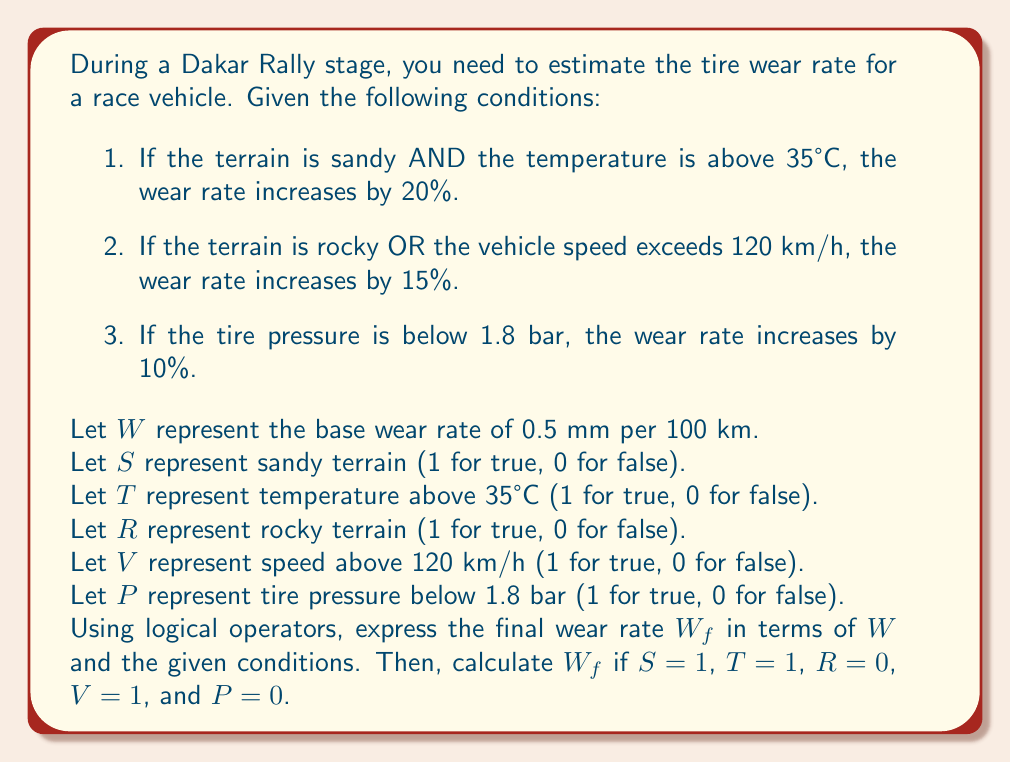Can you answer this question? To solve this problem, we need to express the final wear rate $W_f$ using logical operators and the given conditions. Let's break it down step by step:

1. For the sandy terrain AND high temperature condition:
   $W_1 = W \cdot (1 + 0.2 \cdot (S \land T))$

2. For the rocky terrain OR high speed condition:
   $W_2 = W_1 \cdot (1 + 0.15 \cdot (R \lor V))$

3. For the low tire pressure condition:
   $W_f = W_2 \cdot (1 + 0.1 \cdot P)$

Combining these expressions, we get:

$$W_f = W \cdot (1 + 0.2 \cdot (S \land T)) \cdot (1 + 0.15 \cdot (R \lor V)) \cdot (1 + 0.1 \cdot P)$$

Now, let's calculate $W_f$ for the given values:
$S = 1$, $T = 1$, $R = 0$, $V = 1$, and $P = 0$

Substituting these values:

$$\begin{align*}
W_f &= 0.5 \cdot (1 + 0.2 \cdot (1 \land 1)) \cdot (1 + 0.15 \cdot (0 \lor 1)) \cdot (1 + 0.1 \cdot 0) \\
&= 0.5 \cdot (1 + 0.2 \cdot 1) \cdot (1 + 0.15 \cdot 1) \cdot 1 \\
&= 0.5 \cdot 1.2 \cdot 1.15 \\
&= 0.69 \text{ mm per 100 km}
\end{align*}$$
Answer: The final wear rate $W_f$ is 0.69 mm per 100 km. 